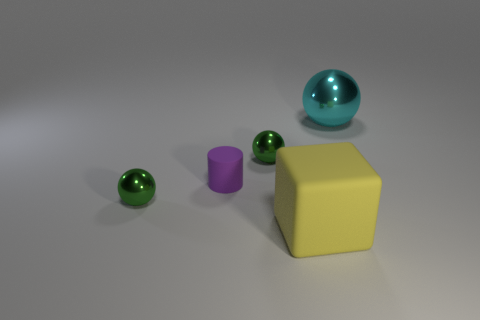How many large cyan cylinders have the same material as the purple object?
Your answer should be compact. 0. There is a metal object that is both in front of the cyan shiny ball and behind the tiny purple thing; what is its shape?
Give a very brief answer. Sphere. Does the large object that is behind the large yellow block have the same material as the tiny purple object?
Offer a terse response. No. Is there any other thing that has the same material as the yellow block?
Your response must be concise. Yes. What color is the metallic sphere that is the same size as the rubber block?
Make the answer very short. Cyan. Is there another rubber cylinder that has the same color as the tiny cylinder?
Your response must be concise. No. What size is the yellow thing that is the same material as the small purple thing?
Offer a very short reply. Large. What number of other things are the same size as the rubber cylinder?
Give a very brief answer. 2. There is a green thing that is behind the purple matte object; what is it made of?
Keep it short and to the point. Metal. What shape is the rubber object to the left of the object in front of the small shiny sphere left of the tiny rubber cylinder?
Provide a short and direct response. Cylinder. 